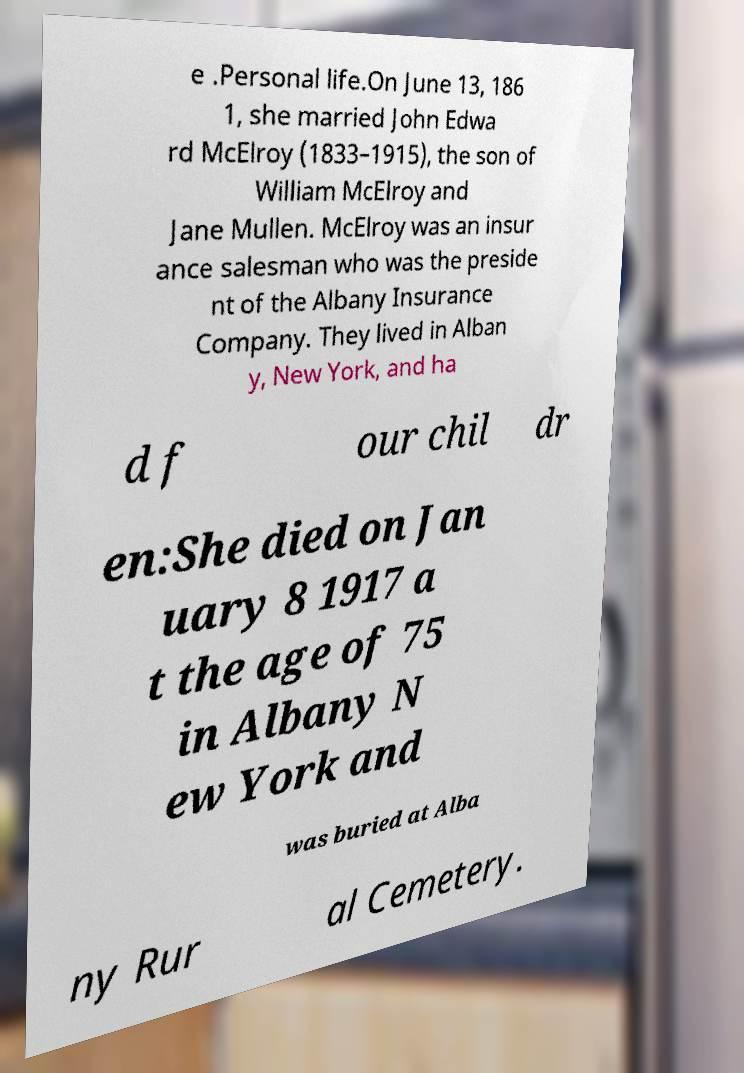Please identify and transcribe the text found in this image. e .Personal life.On June 13, 186 1, she married John Edwa rd McElroy (1833–1915), the son of William McElroy and Jane Mullen. McElroy was an insur ance salesman who was the preside nt of the Albany Insurance Company. They lived in Alban y, New York, and ha d f our chil dr en:She died on Jan uary 8 1917 a t the age of 75 in Albany N ew York and was buried at Alba ny Rur al Cemetery. 